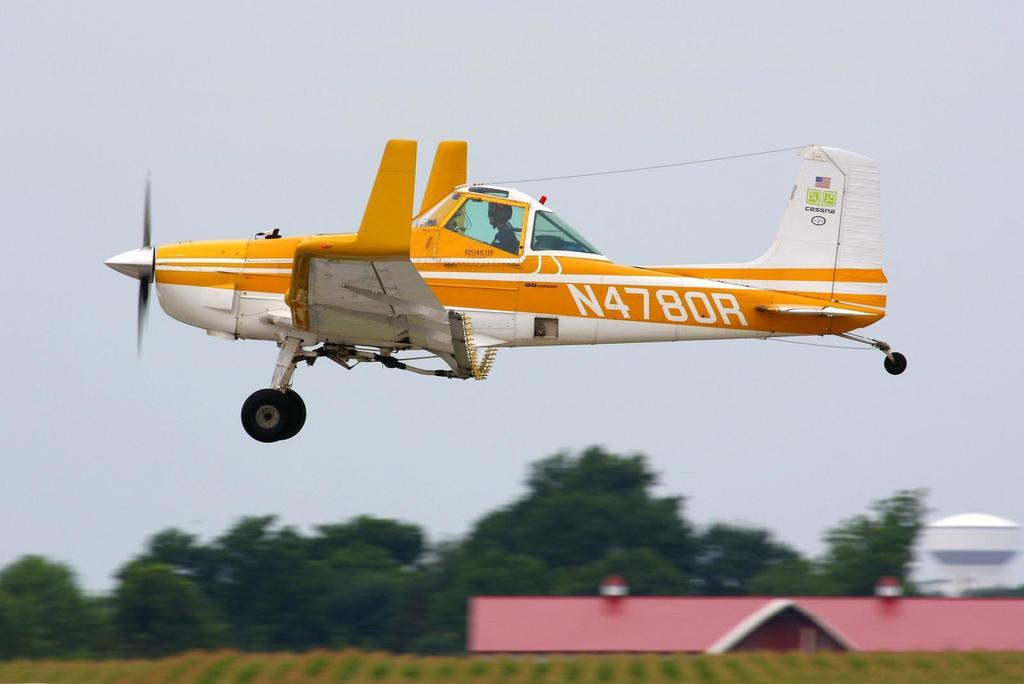<image>
Summarize the visual content of the image. A little airplane with the number N4780R flies close to the ground. 